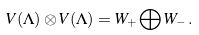Convert formula to latex. <formula><loc_0><loc_0><loc_500><loc_500>V ( \Lambda ) \otimes V ( \Lambda ) = W _ { + } \bigoplus W _ { - } \, .</formula> 